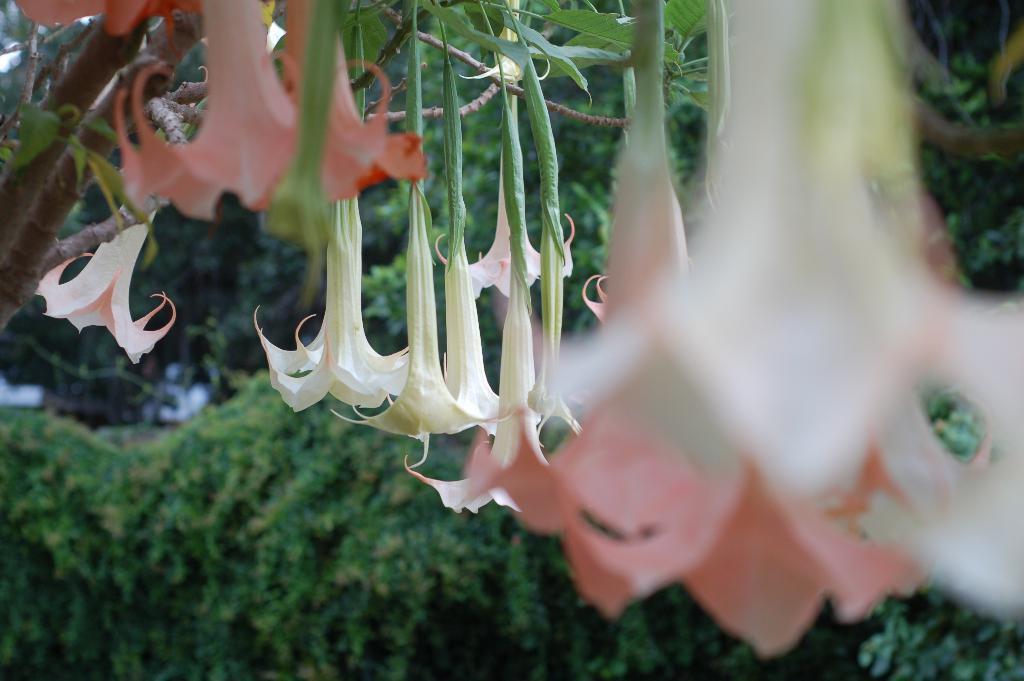Could you give a brief overview of what you see in this image? In the foreground of this image, there are flowers up side down hanging to the tree and in the background, there is greenery. 